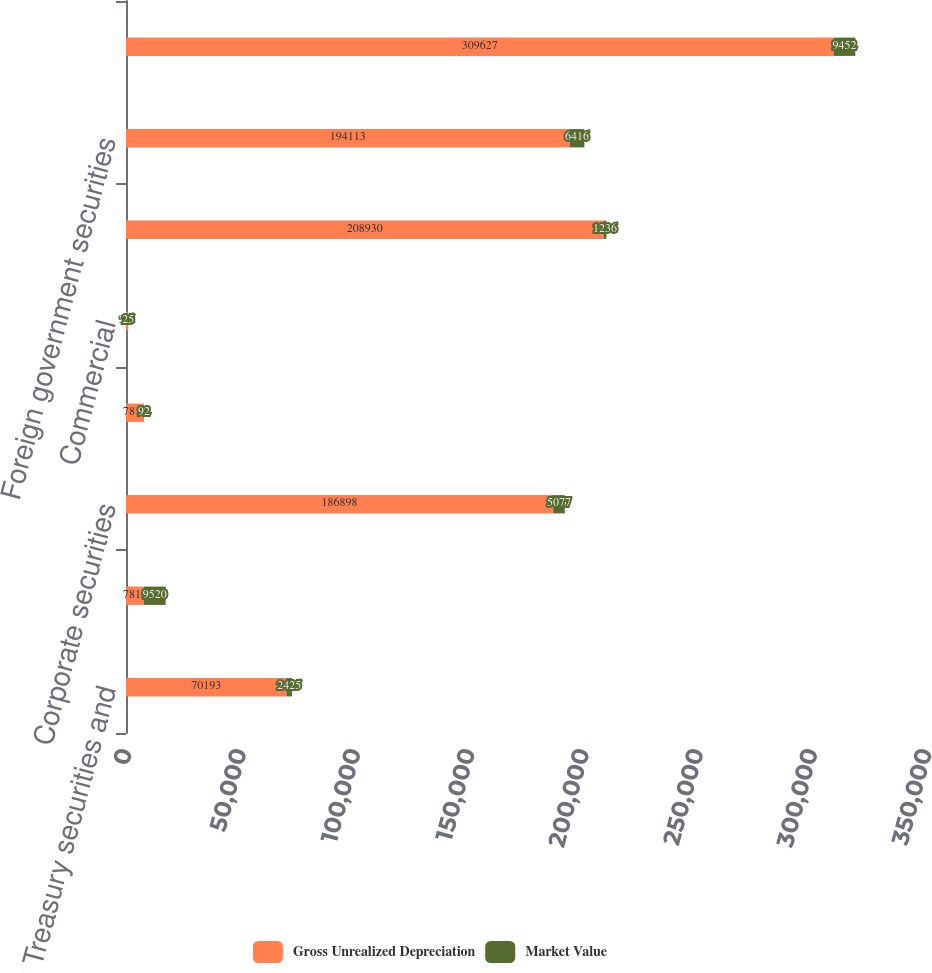Convert chart to OTSL. <chart><loc_0><loc_0><loc_500><loc_500><stacked_bar_chart><ecel><fcel>US Treasury securities and<fcel>Obligations of US states and<fcel>Corporate securities<fcel>Asset-backed securities<fcel>Commercial<fcel>Agency residential<fcel>Foreign government securities<fcel>Foreign corporate securities<nl><fcel>Gross Unrealized Depreciation<fcel>70193<fcel>7816<fcel>186898<fcel>7816<fcel>962<fcel>208930<fcel>194113<fcel>309627<nl><fcel>Market Value<fcel>2425<fcel>9520<fcel>5077<fcel>92<fcel>25<fcel>1236<fcel>6416<fcel>9452<nl></chart> 